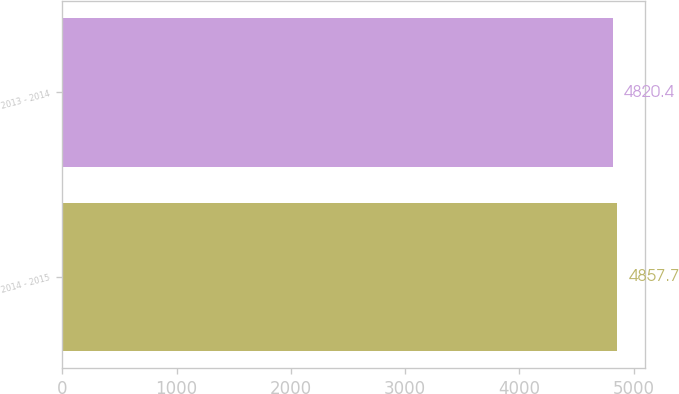Convert chart to OTSL. <chart><loc_0><loc_0><loc_500><loc_500><bar_chart><fcel>2014 - 2015<fcel>2013 - 2014<nl><fcel>4857.7<fcel>4820.4<nl></chart> 